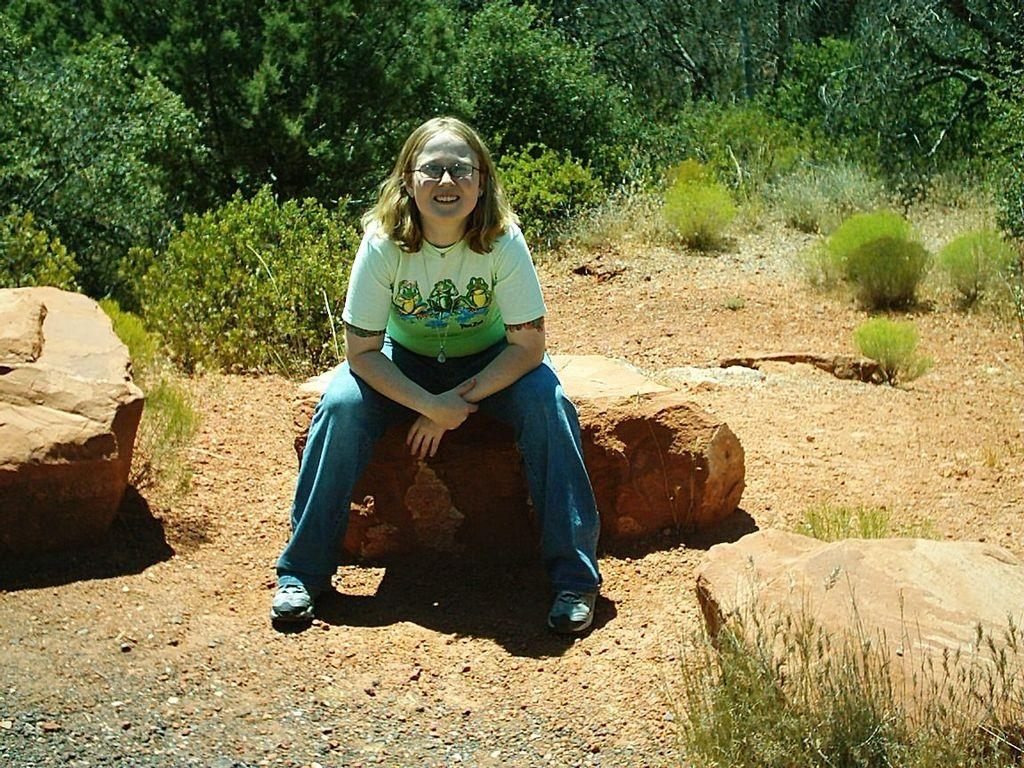What is the woman doing in the image? The woman is sitting on a rock in the image. What can be seen in the background of the image? There are plants and trees in the background of the image. What type of potato is the woman holding in the image? There is no potato present in the image; the woman is sitting on a rock with plants and trees in the background. 